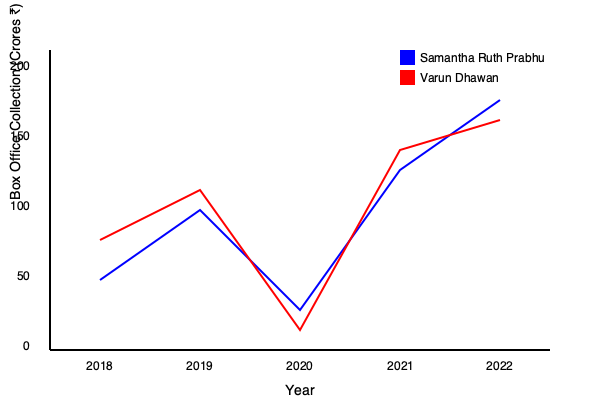Analyze the box office trends of Samantha Ruth Prabhu and Varun Dhawan's films from 2018 to 2022. Which actor showed a more consistent upward trend in their box office collections, and what was the difference in their collections for the year 2022? To analyze the box office trends and answer the question, let's follow these steps:

1. Examine the trends for both actors:
   - Samantha Ruth Prabhu (blue line):
     2018: ₹70 crores
     2019: ₹140 crores
     2020: ₹40 crores
     2021: ₹180 crores
     2022: ₹250 crores

   - Varun Dhawan (red line):
     2018: ₹110 crores
     2019: ₹160 crores
     2020: ₹20 crores
     2021: ₹200 crores
     2022: ₹230 crores

2. Analyze the consistency of the upward trend:
   Samantha Ruth Prabhu shows a more consistent upward trend, with a significant increase from 2018 to 2019, a dip in 2020 (likely due to the pandemic), and then a strong recovery in 2021 and 2022.
   Varun Dhawan's trend is similar but less pronounced, with a smaller increase from 2018 to 2019 and a less steep recovery in 2021 and 2022.

3. Calculate the difference in collections for 2022:
   Samantha Ruth Prabhu: ₹250 crores
   Varun Dhawan: ₹230 crores
   Difference: ₹250 crores - ₹230 crores = ₹20 crores

Therefore, Samantha Ruth Prabhu showed a more consistent upward trend in box office collections, and the difference in their collections for 2022 was ₹20 crores, with Samantha Ruth Prabhu earning more.
Answer: Samantha Ruth Prabhu; ₹20 crores 